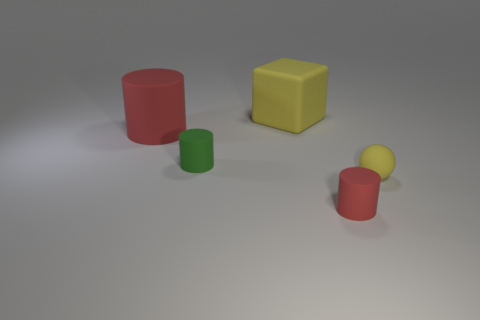Add 5 large cylinders. How many objects exist? 10 Subtract all cubes. How many objects are left? 4 Add 3 tiny rubber spheres. How many tiny rubber spheres exist? 4 Subtract 0 yellow cylinders. How many objects are left? 5 Subtract all large red rubber cylinders. Subtract all small red cylinders. How many objects are left? 3 Add 1 red rubber objects. How many red rubber objects are left? 3 